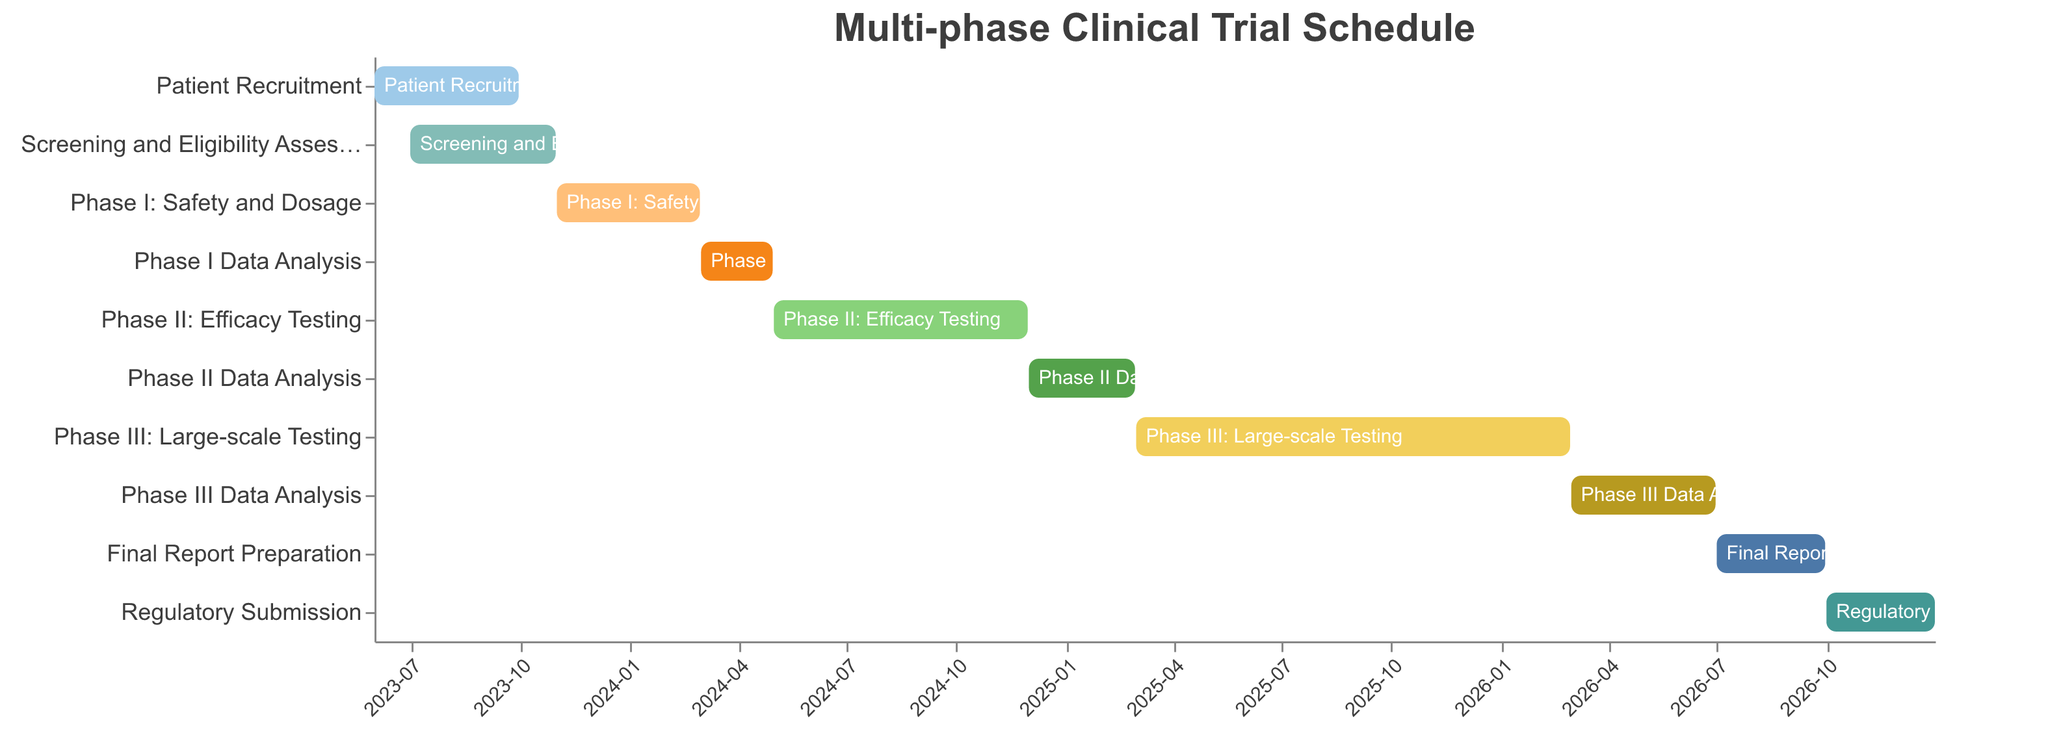What is the title of the chart? The title is displayed at the top of the chart. It usually summarizes the main content of the figure.
Answer: Multi-phase Clinical Trial Schedule How long is the Patient Recruitment phase? Check the "Patient Recruitment" bar to observe the start and end dates. Subtract the start date from the end date to compute the duration. The phase spans from June 1, 2023, to September 30, 2023.
Answer: 4 months During which phases do Screening and Eligibility Assessment and Phase I: Safety and Dosage overlap? Check the dates for the "Screening and Eligibility Assessment" (July 1, 2023 to October 31, 2023) and "Phase I: Safety and Dosage" (November 1, 2023 to February 29, 2024). Observe if the dates overlap.
Answer: No overlap What is the longest phase in the schedule? Compare the duration of all phases by checking the start and end dates for each task. The longest phase is the one with the greatest time span.
Answer: Phase III: Large-scale Testing How many months are dedicated to data analysis in total? Identify all data analysis phases: "Phase I Data Analysis," "Phase II Data Analysis," and "Phase III Data Analysis". Sum the durations of these phases: March 1, 2024 - April 30, 2024 (2 months), December 1, 2024 - February 28, 2025 (3 months), and March 1, 2026 - June 30, 2026 (4 months).
Answer: 9 months Which task immediately precedes the Regulatory Submission phase? Look at the Gantt chart to identify the task just before the "Regulatory Submission" phase (October 1, 2026 - December 31, 2026). The task immediately before it is "Final Report Preparation."
Answer: Final Report Preparation When does the Final Report Preparation start and end? Observe the "Final Report Preparation" bar from the start to end date.
Answer: July 1, 2026 - September 30, 2026 Which phases are overlapping during October 2023? Check all bars for phases active during October 2023 by matching their duration with the given month. The relevant phases are "Screening and Eligibility Assessment" and "Patient Recruitment."
Answer: Screening and Eligibility Assessment How much time is allocated to Phase I: Safety and Dosage and its data analysis combined? Determine the duration of "Phase I: Safety and Dosage" (November 1, 2023 - February 29, 2024; 4 months) and "Phase I Data Analysis" (March 1, 2024 - April 30, 2024; 2 months). Sum these durations.
Answer: 6 months Is there any gap between Phase II Data Analysis and Phase III: Large-scale Testing? Check the end date of "Phase II Data Analysis" (February 28, 2025) and the start date of "Phase III: Large-scale Testing" (March 1, 2025). Determine if there’s an interval between the two phases.
Answer: No gap 